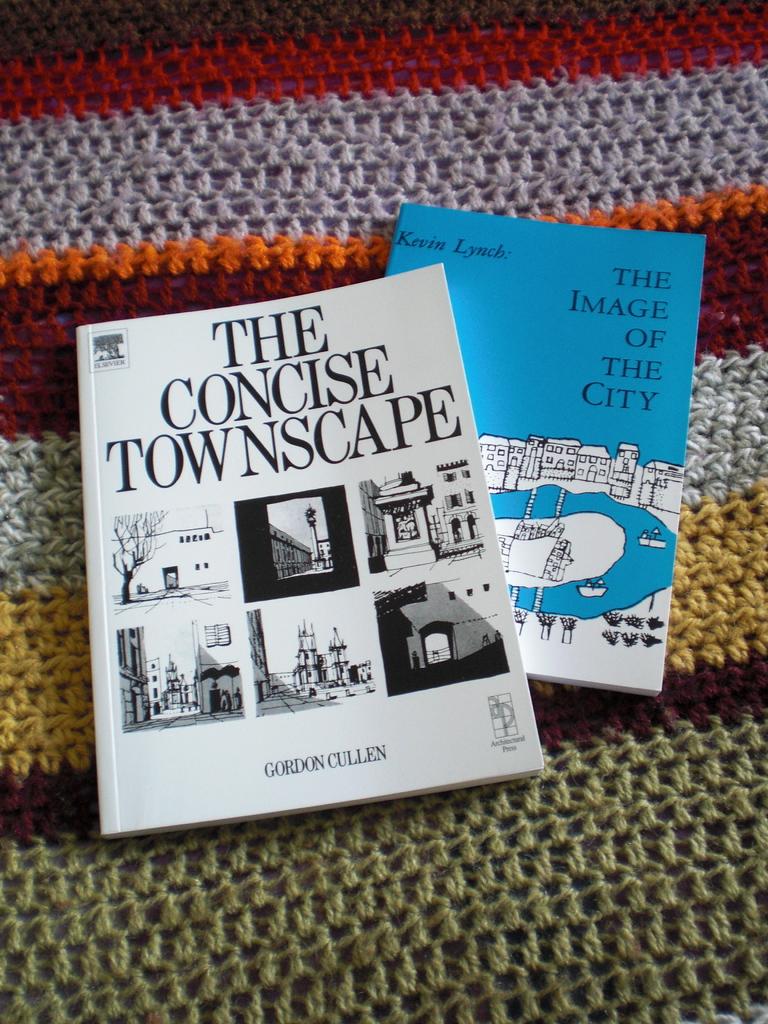What is the title of the blue book?
Your answer should be very brief. The image of the city. What´s the tittle of the white book?
Ensure brevity in your answer.  The concise townscape. 